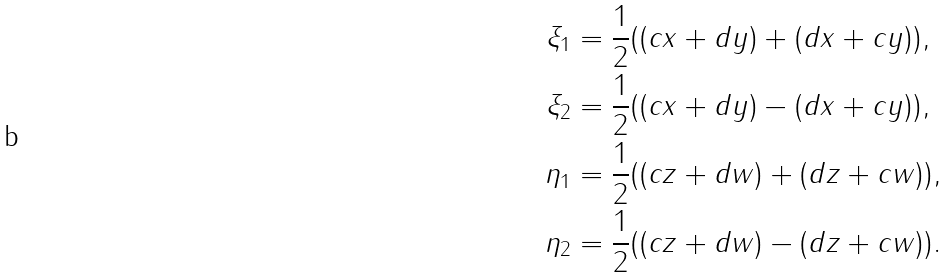<formula> <loc_0><loc_0><loc_500><loc_500>\xi _ { 1 } & = \frac { 1 } { 2 } ( ( c x + d y ) + ( d x + c y ) ) , \\ \xi _ { 2 } & = \frac { 1 } { 2 } ( ( c x + d y ) - ( d x + c y ) ) , \\ \eta _ { 1 } & = \frac { 1 } { 2 } ( ( c z + d w ) + ( d z + c w ) ) , \\ \eta _ { 2 } & = \frac { 1 } { 2 } ( ( c z + d w ) - ( d z + c w ) ) .</formula> 